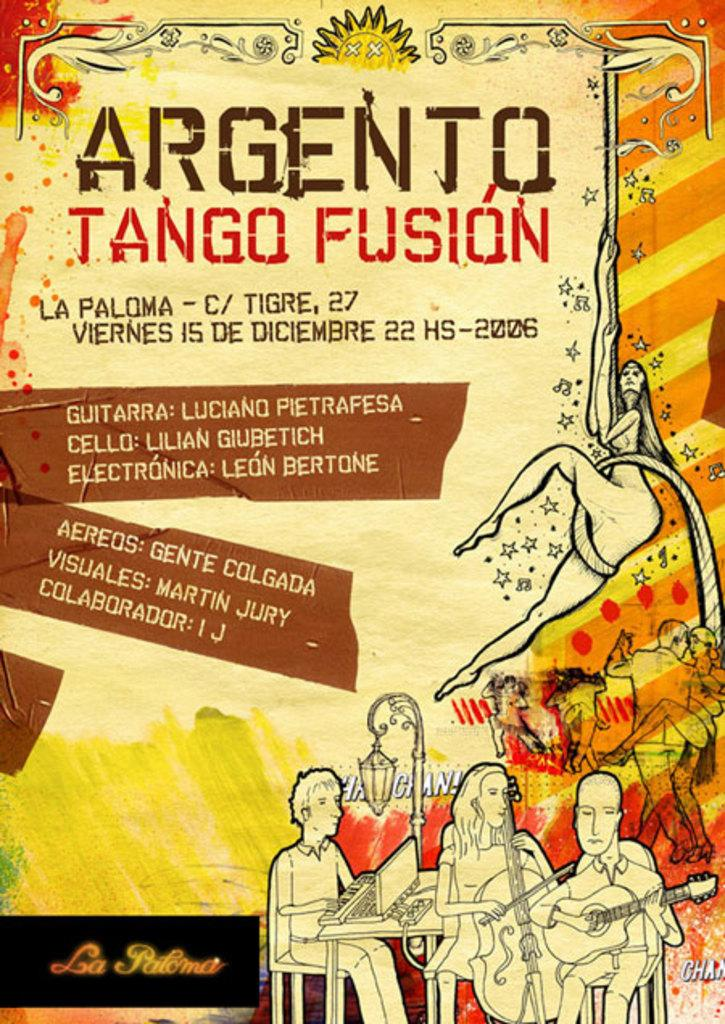<image>
Write a terse but informative summary of the picture. A poster for Argento Tango Fusion with three people playing instruments at the bottom. 